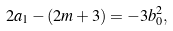<formula> <loc_0><loc_0><loc_500><loc_500>2 a _ { 1 } - ( 2 m + 3 ) = - 3 b _ { 0 } ^ { 2 } ,</formula> 